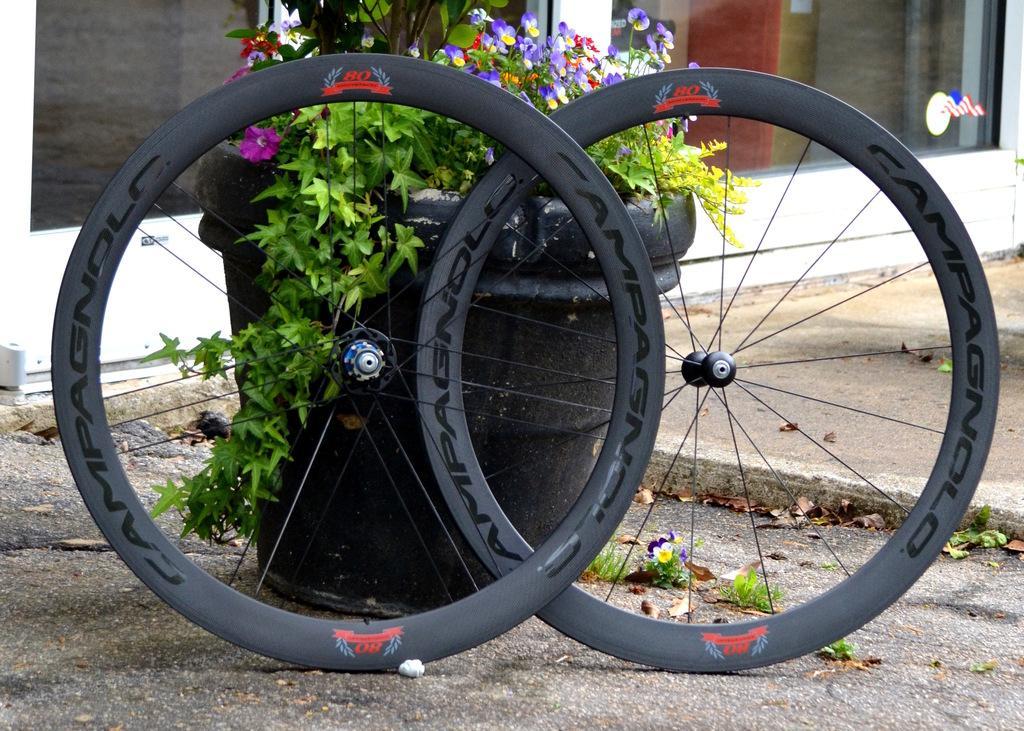How would you summarize this image in a sentence or two? In this image we can see some plants in the pots and the tires which are placed on the ground. On the backside we can see a glass window. 